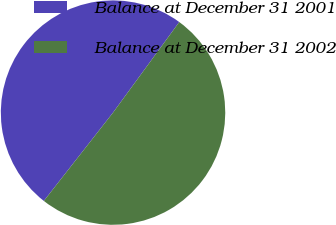Convert chart to OTSL. <chart><loc_0><loc_0><loc_500><loc_500><pie_chart><fcel>Balance at December 31 2001<fcel>Balance at December 31 2002<nl><fcel>49.47%<fcel>50.53%<nl></chart> 